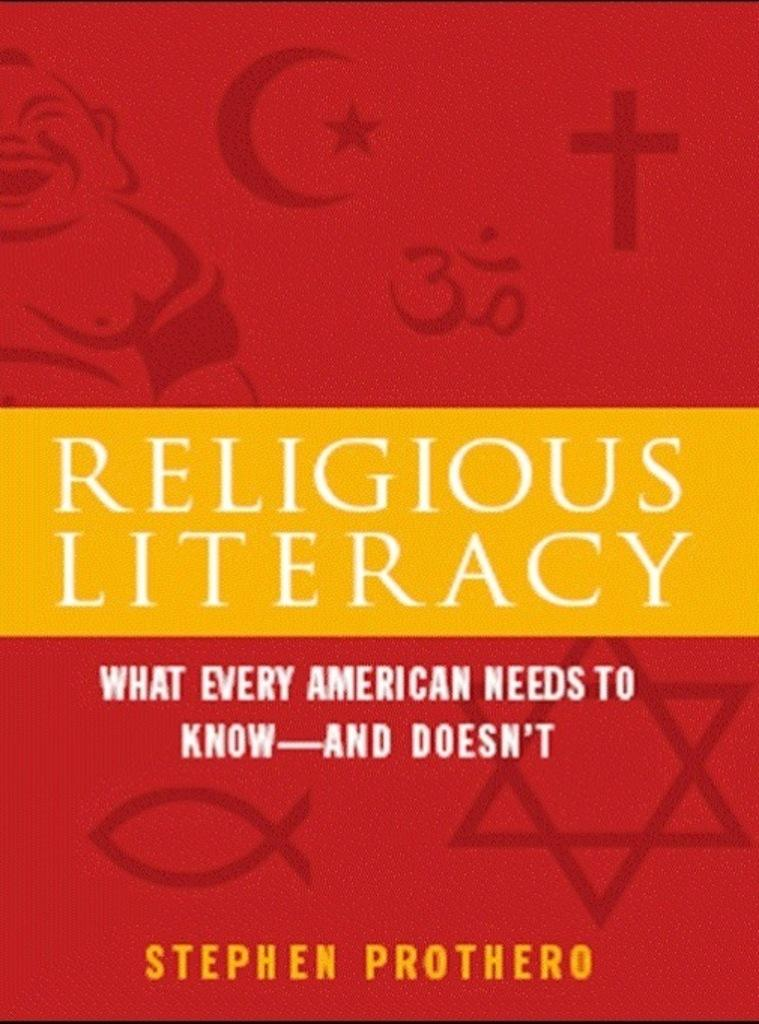<image>
Describe the image concisely. A book entitles Religious Literacy by Stephen Prothero features a bright red and yellow cover. 